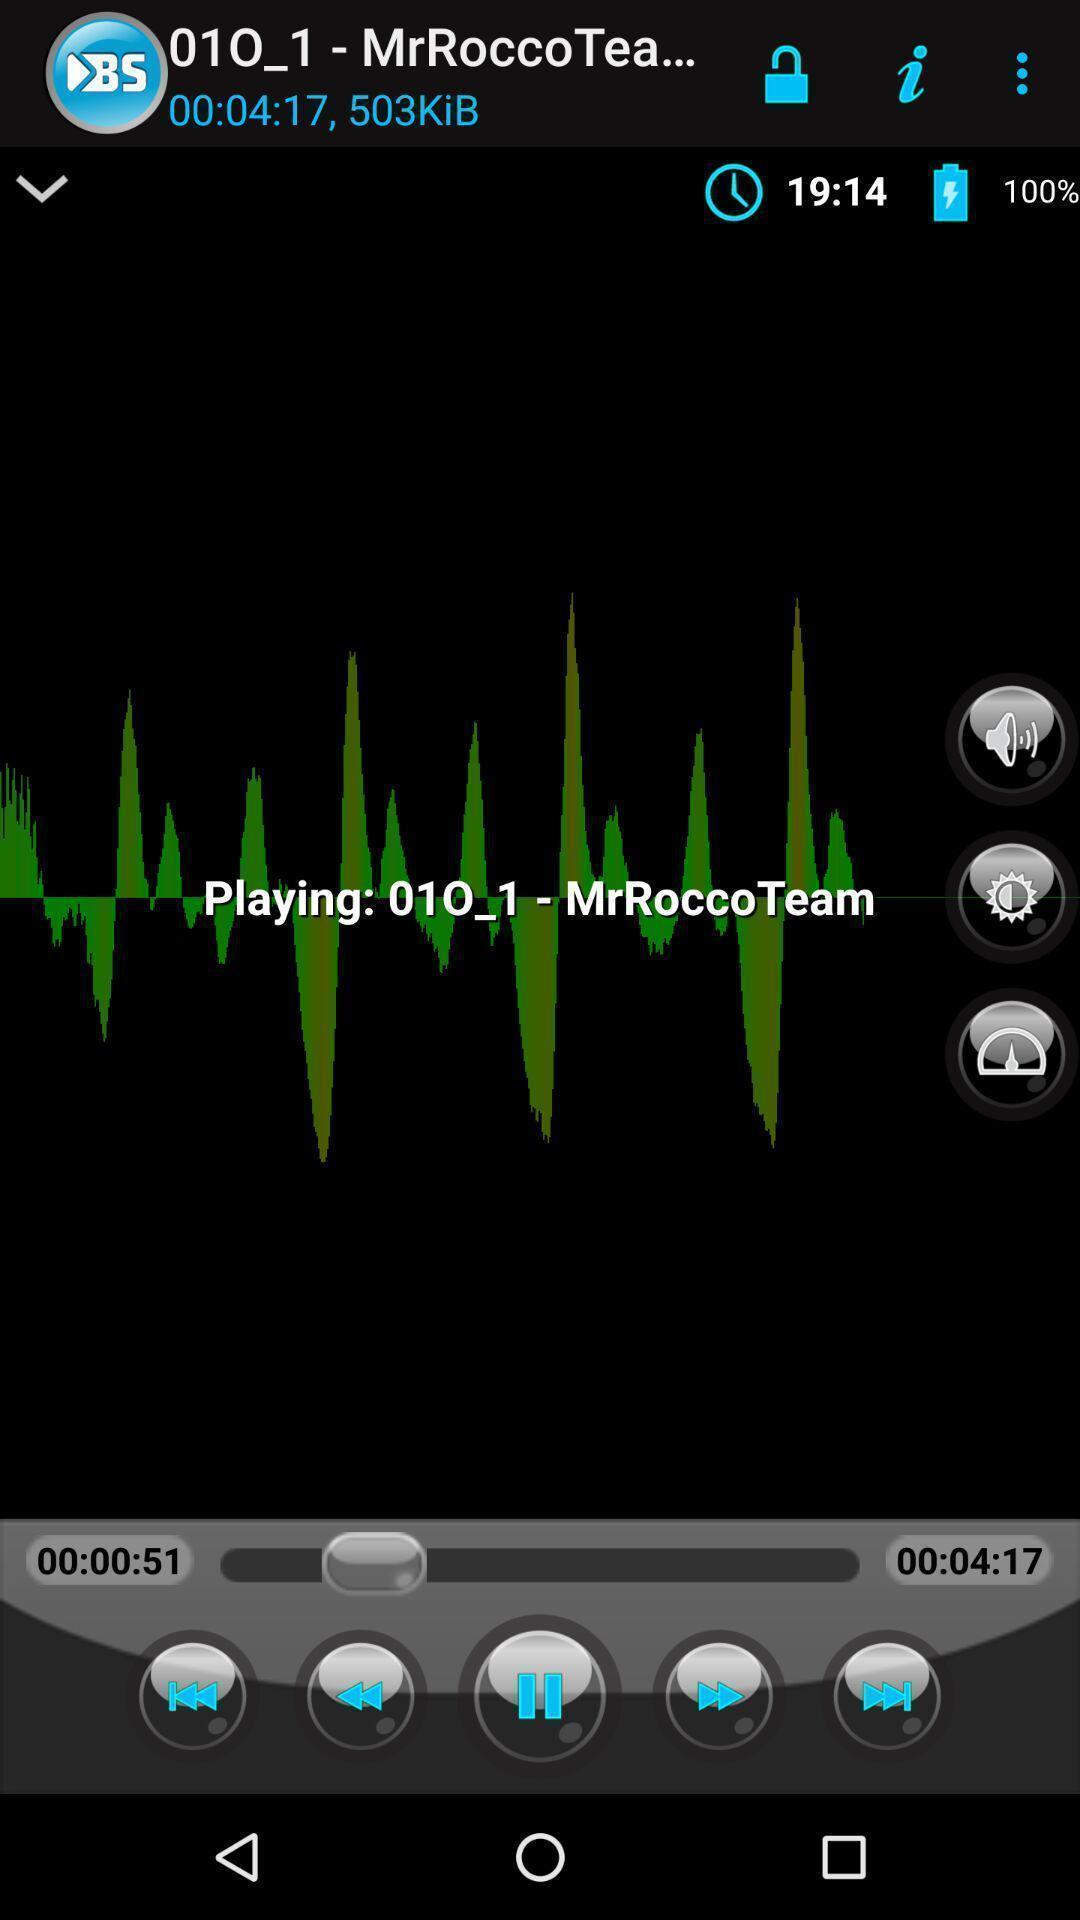Describe this image in words. Playing a music in music application. 